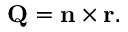Convert formula to latex. <formula><loc_0><loc_0><loc_500><loc_500>Q = n \times r .</formula> 